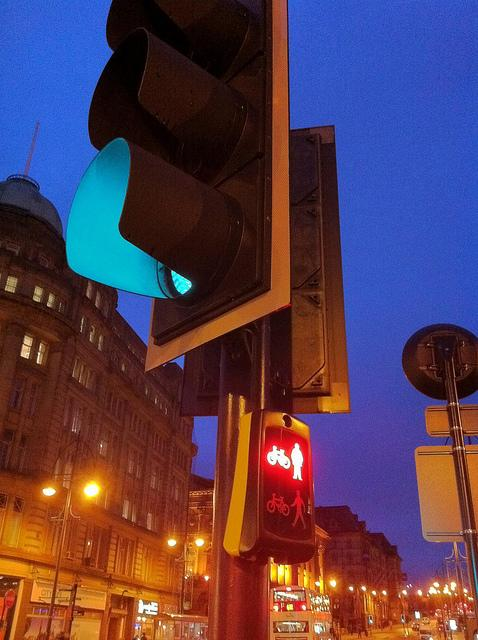What does the bottom red light prohibit? Please explain your reasoning. crossing. The red light keeps people from crossing the street. 